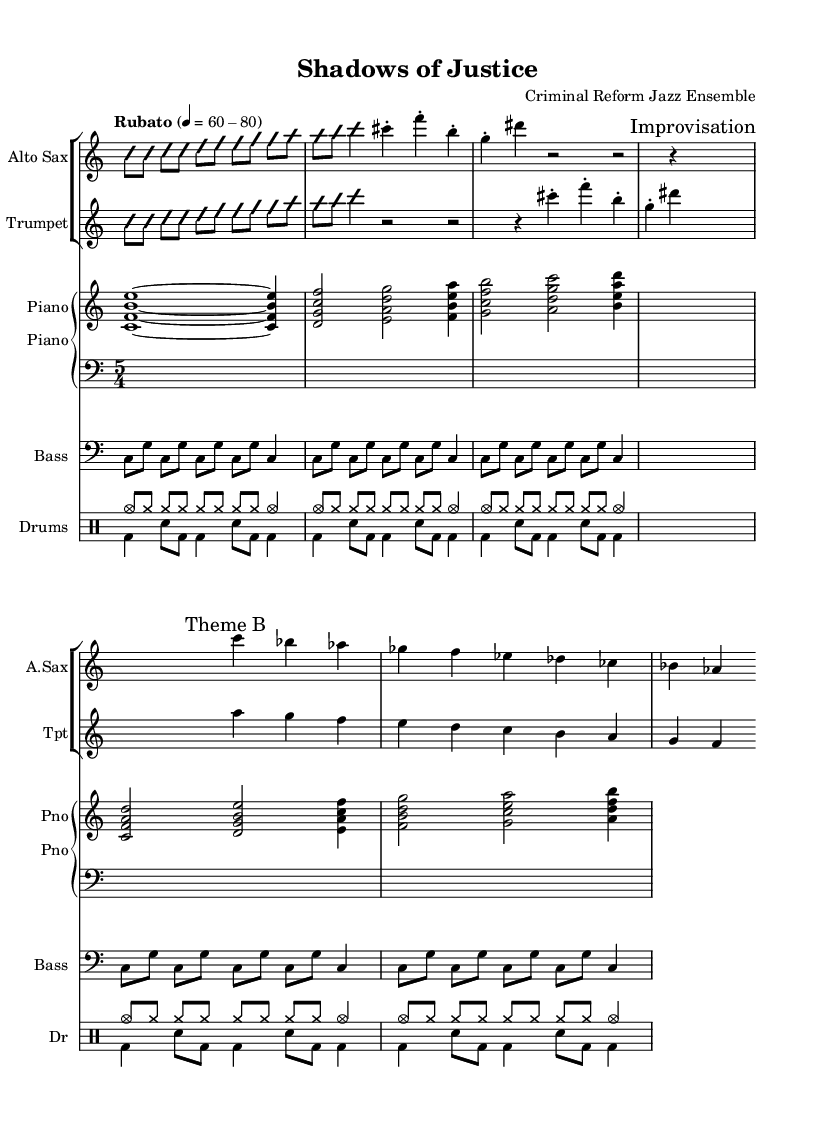What is the time signature of this piece? The time signature is indicated at the beginning of the score. Here, it is written as 5/4, which denotes five beats per measure, with the quarter note receiving one beat.
Answer: 5/4 What is the tempo marking of this composition? The tempo marking is found at the start of the score, specified as "Rubato" with a metronome marking of 60-80, indicating a free tempo with flexibility in the rhythm.
Answer: Rubato 60-80 How many main themes are present in this piece? Counting the distinct themes in the score, there are two main themes labeled as "Theme A" and "Theme B." This is evident as both themes are introduced separately within the music.
Answer: 2 Which instruments are prominently featured in this jazz piece? The instruments are specified at the beginning of each staff. The piece features Alto Sax, Trumpet, Piano, Bass, and Drums, which are typical in jazz ensembles, contributing to its character.
Answer: Alto Sax, Trumpet, Piano, Bass, Drums What type of improvisation is indicated in the score? The score contains sections labeled as "Improvisation," where performers can freely embellish notes or make up melodies. These hints encourage spontaneous expressions characteristic of jazz music.
Answer: Improvisation What is the primary key of "Shadows of Justice"? The key is not explicitly marked on the sheet music, but analyzing the notes and chords suggests that the piece is centered around the C major scale, which is commonly used in jazz compositions.
Answer: C major 